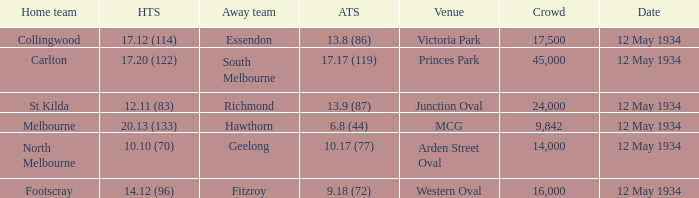What was the score of the away team while playing at the arden street oval? 10.17 (77). 